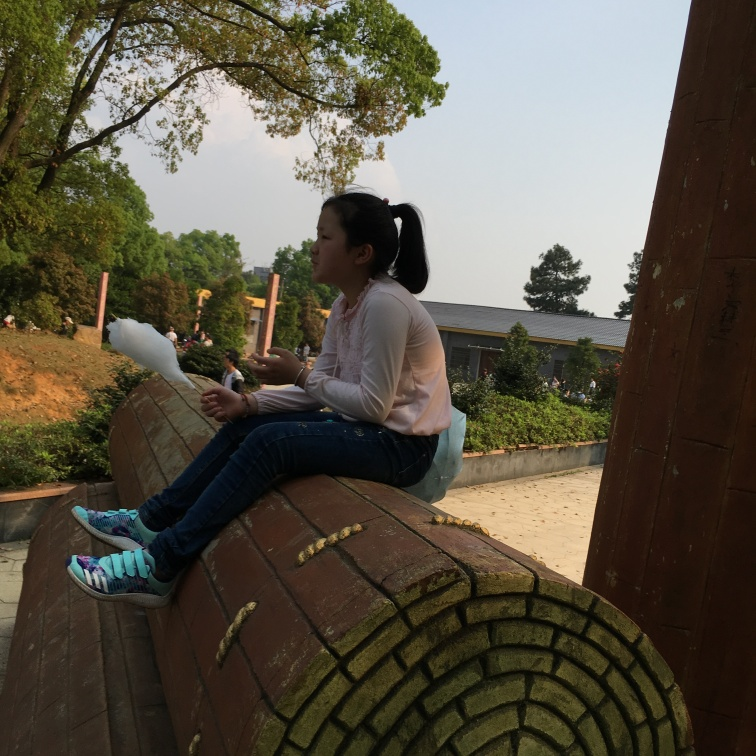Are there any cultural or regional clues in this image? The architecture, particularly the roof tiles and their arrangement, along with the vegetation around, suggest an East Asian setting. The attire of the subject also seems casual and comfortable, suitable for a relaxed outdoor environment in a temperate climate. 